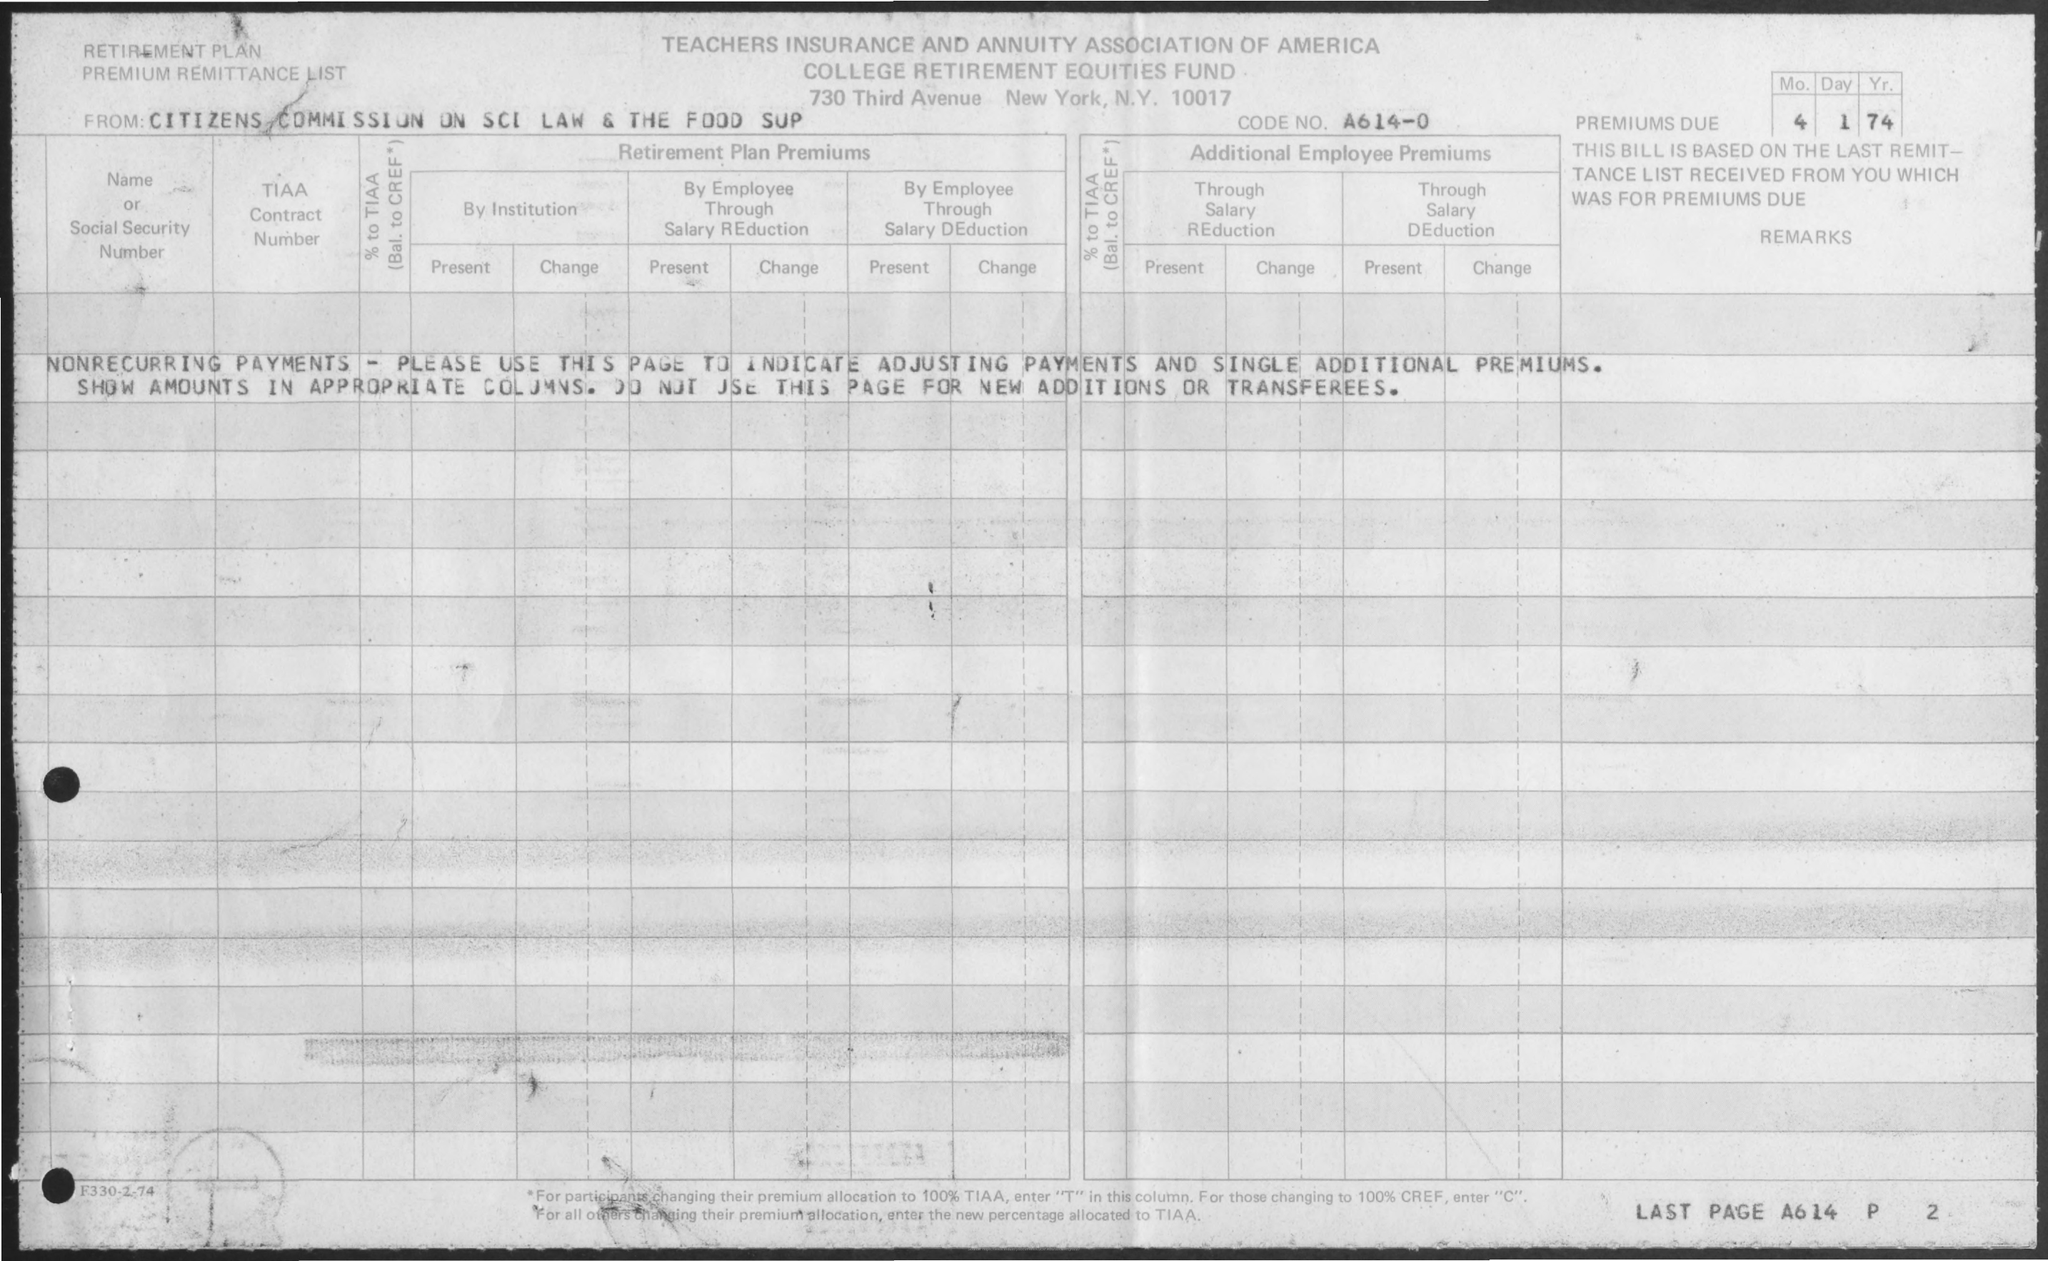What type of document is this, and what purpose does it serve? This appears to be a historical document from the Teachers Insurance and Annuity Association of America, specifically a retirement plan premium remittance list. Its purpose is to record the details of retirement plan premiums due, such as the contributing institution and employee payments, adjustments, and non-recurring payments. 